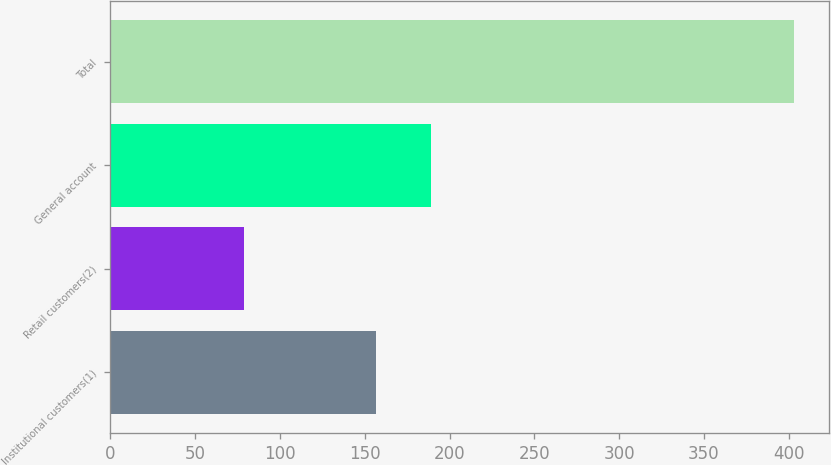<chart> <loc_0><loc_0><loc_500><loc_500><bar_chart><fcel>Institutional customers(1)<fcel>Retail customers(2)<fcel>General account<fcel>Total<nl><fcel>156.8<fcel>79<fcel>189.24<fcel>403.4<nl></chart> 